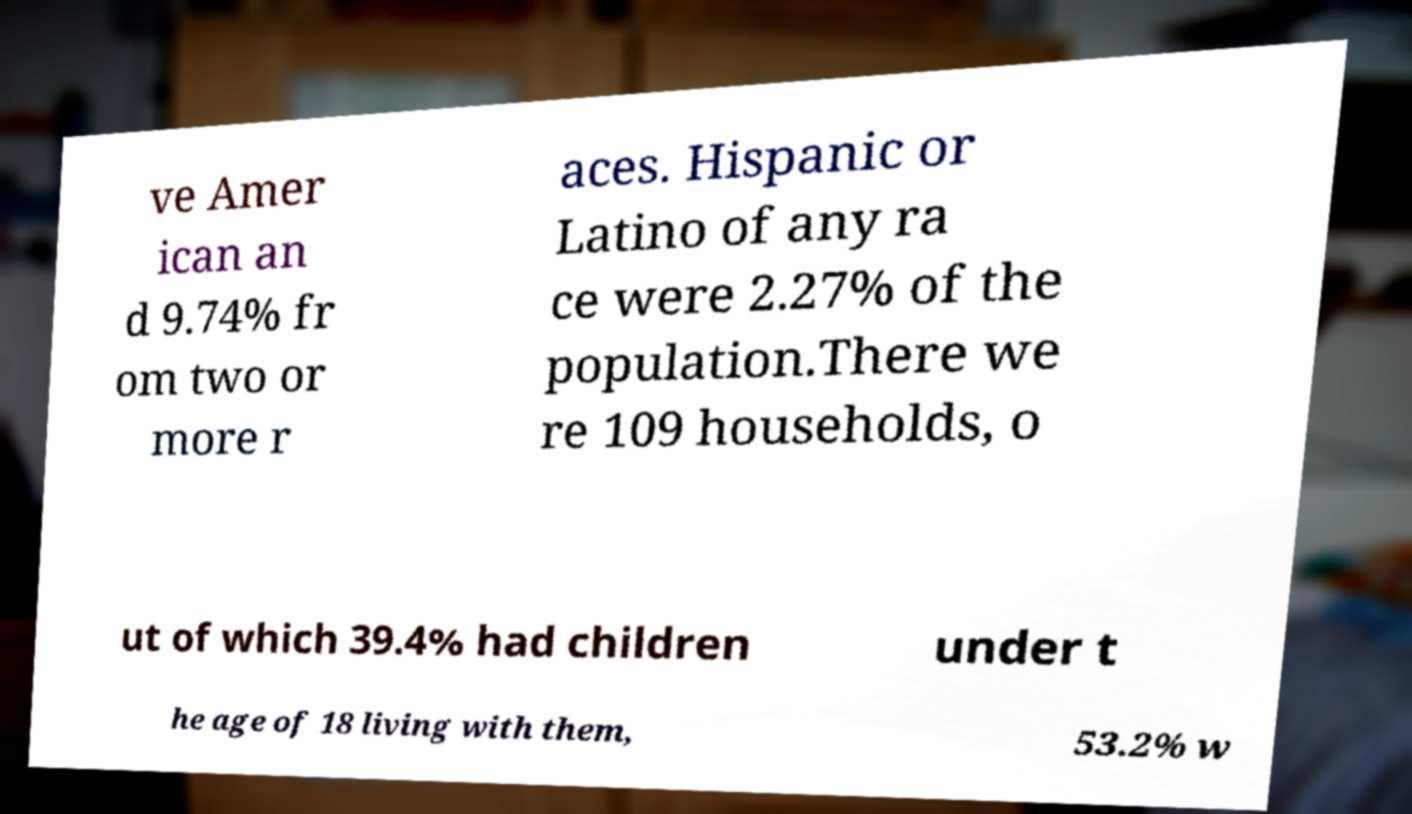What messages or text are displayed in this image? I need them in a readable, typed format. ve Amer ican an d 9.74% fr om two or more r aces. Hispanic or Latino of any ra ce were 2.27% of the population.There we re 109 households, o ut of which 39.4% had children under t he age of 18 living with them, 53.2% w 